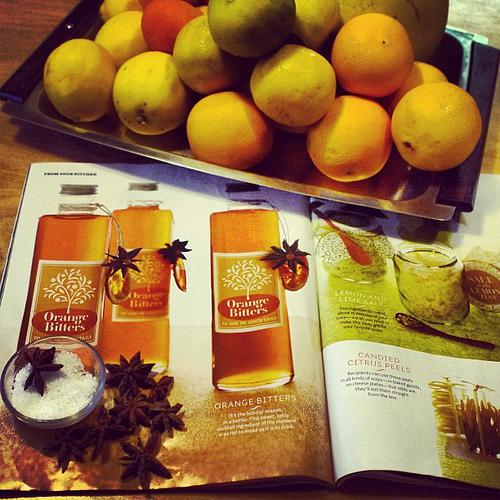Question: what is under the tray of oranges?
Choices:
A. A napkin.
B. A towel.
C. A book.
D. Magazine.
Answer with the letter. Answer: D Question: what spice is on the counter?
Choices:
A. Anise.
B. Parsley powder.
C. Garlic powder.
D. Onion powder.
Answer with the letter. Answer: A Question: how many bottles are in the picture?
Choices:
A. Four.
B. Five.
C. Two.
D. Three.
Answer with the letter. Answer: D Question: what is the advertisement for?
Choices:
A. New car.
B. Orange bitters.
C. An iphone cell phone.
D. An LG tv.
Answer with the letter. Answer: B Question: what is on the tray?
Choices:
A. Oranges.
B. Apples.
C. Bread.
D. Cookies.
Answer with the letter. Answer: A Question: what type of handles are on the tray?
Choices:
A. Wood.
B. Plastic.
C. Steel.
D. Brass.
Answer with the letter. Answer: A 